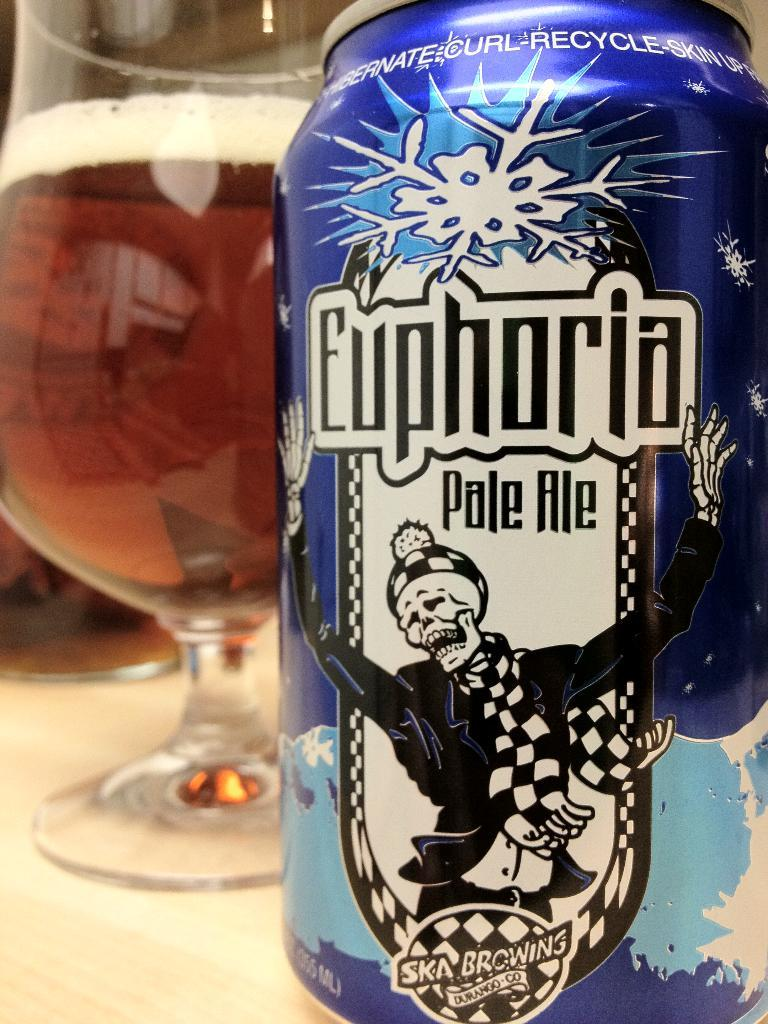<image>
Present a compact description of the photo's key features. A BLUE CAN WITH A SKELETON ON IT CALLED EUPHORIA PALE ALE 